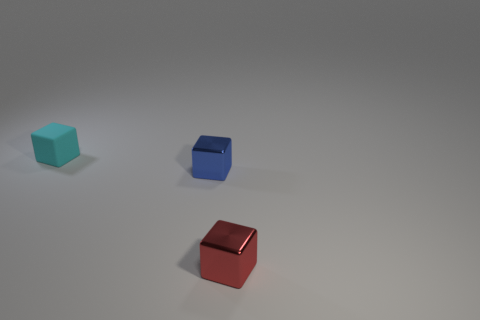If these objects were part of a game, what could be their potential roles? In a game setting, the red cube could represent a powerful piece, perhaps a 'leader' due to its distinct color. The blue cube might be a 'defender' or 'guardian' type piece, whereas the teal cube might be utilized for resource collection or other strategic roles. 